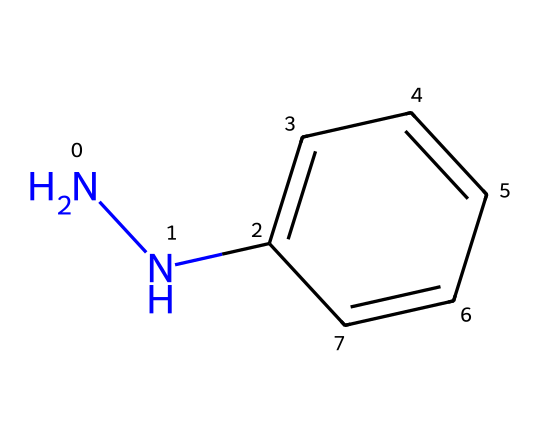What is the molecular formula of phenylhydrazine? By analyzing the SMILES representation, we can identify that it contains 6 carbon atoms from the phenyl group (c1ccccc1), 4 hydrogen atoms from the phenyl group, and 2 nitrogen atoms (NN) linked to the phenyl group. Thus, the total counts lead to the molecular formula C6H8N2.
Answer: C6H8N2 How many nitrogen atoms are present in this structure? The SMILES notation includes 'NN', indicating the presence of two nitrogen (N) atoms.
Answer: 2 What type of functional group is present in phenylhydrazine? The structure contains hydrazine (-NN-) as part of the functional group, which is characteristic of hydrazines. Additionally, the linkage to a phenyl group describes it specifically as a hydrazine derivative.
Answer: hydrazine What role does phenylhydrazine typically play in organic synthesis? Phenylhydrazine is primarily used as a reagent in the synthesis of hydrazones and is also utilized in the testing of ketones and aldehydes. Therefore, it acts as a building block for deriving other compounds in organic synthesis processes.
Answer: reagent Can you identify the bonding nature around the nitrogen atoms in phenylhydrazine? The nitrogen atoms are connected by a single bond, indicating they are part of the hydrazine functional group. The bonding does not indicate resonance or double bonds, thus confirming a straightforward single bond arrangement.
Answer: single bond 